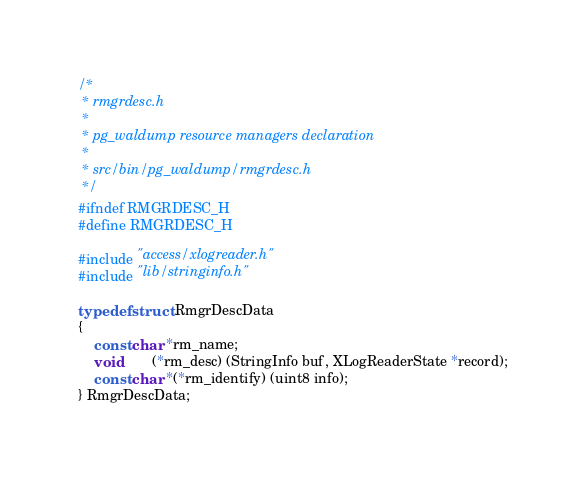<code> <loc_0><loc_0><loc_500><loc_500><_C_>/*
 * rmgrdesc.h
 *
 * pg_waldump resource managers declaration
 *
 * src/bin/pg_waldump/rmgrdesc.h
 */
#ifndef RMGRDESC_H
#define RMGRDESC_H

#include "access/xlogreader.h"
#include "lib/stringinfo.h"

typedef struct RmgrDescData
{
	const char *rm_name;
	void		(*rm_desc) (StringInfo buf, XLogReaderState *record);
	const char *(*rm_identify) (uint8 info);
} RmgrDescData;
</code> 